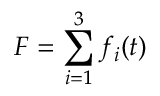<formula> <loc_0><loc_0><loc_500><loc_500>F = \sum _ { i = 1 } ^ { 3 } f _ { i } ( t )</formula> 